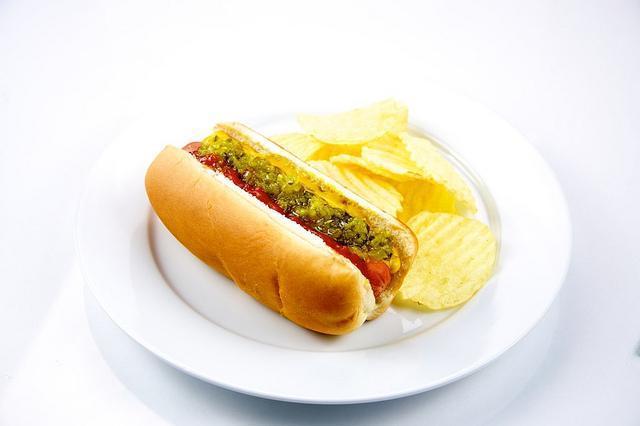How many people holds a cup?
Give a very brief answer. 0. 